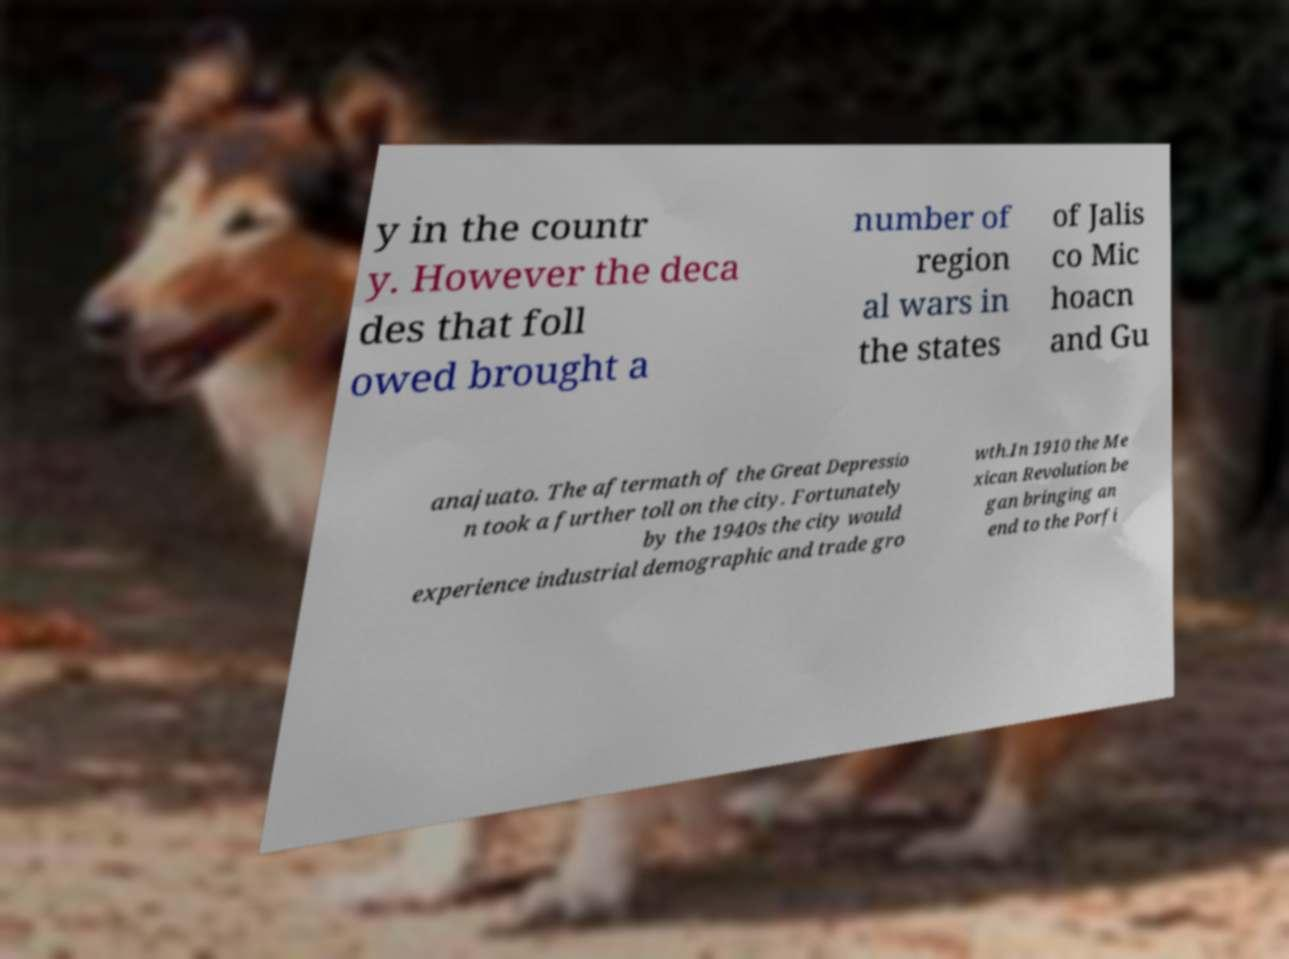Please read and relay the text visible in this image. What does it say? y in the countr y. However the deca des that foll owed brought a number of region al wars in the states of Jalis co Mic hoacn and Gu anajuato. The aftermath of the Great Depressio n took a further toll on the city. Fortunately by the 1940s the city would experience industrial demographic and trade gro wth.In 1910 the Me xican Revolution be gan bringing an end to the Porfi 